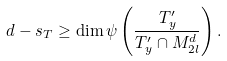<formula> <loc_0><loc_0><loc_500><loc_500>d - s _ { T } \geq \dim \psi \left ( \frac { T _ { y } ^ { \prime } } { T _ { y } ^ { \prime } \cap M _ { 2 l } ^ { d } } \right ) .</formula> 